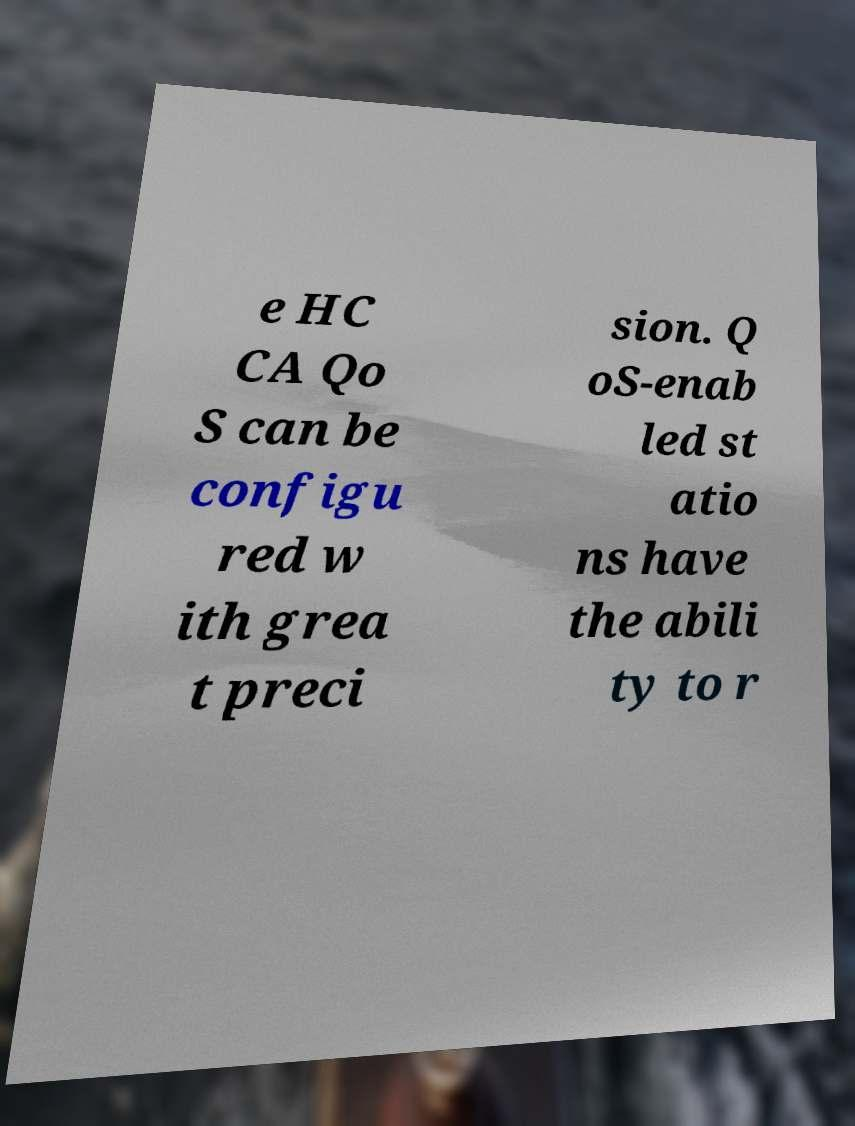For documentation purposes, I need the text within this image transcribed. Could you provide that? e HC CA Qo S can be configu red w ith grea t preci sion. Q oS-enab led st atio ns have the abili ty to r 